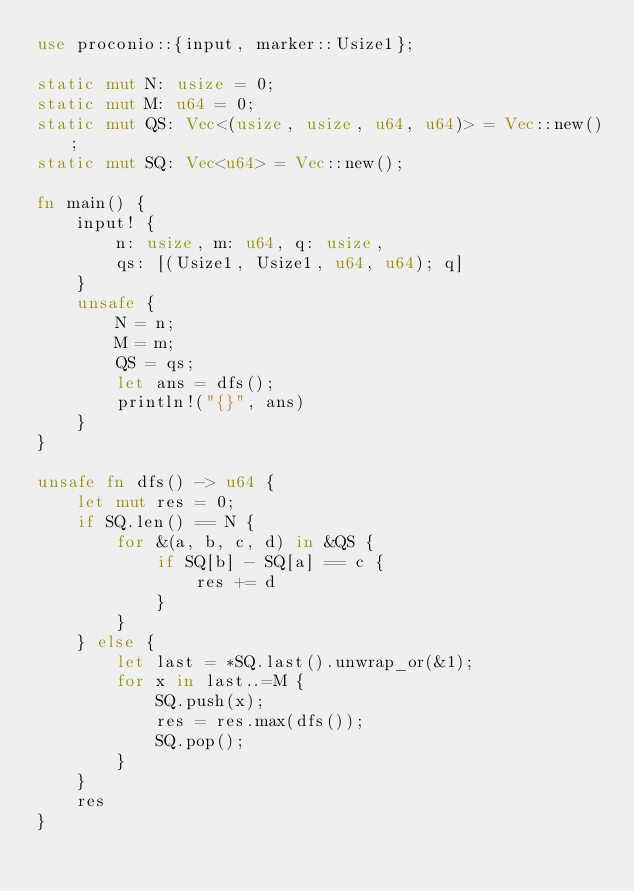<code> <loc_0><loc_0><loc_500><loc_500><_Rust_>use proconio::{input, marker::Usize1};

static mut N: usize = 0;
static mut M: u64 = 0;
static mut QS: Vec<(usize, usize, u64, u64)> = Vec::new();
static mut SQ: Vec<u64> = Vec::new();

fn main() {
    input! {
        n: usize, m: u64, q: usize,
        qs: [(Usize1, Usize1, u64, u64); q]
    }
    unsafe {
        N = n;
        M = m;
        QS = qs;
        let ans = dfs();
        println!("{}", ans)
    }
}

unsafe fn dfs() -> u64 {
    let mut res = 0;
    if SQ.len() == N {
        for &(a, b, c, d) in &QS {
            if SQ[b] - SQ[a] == c {
                res += d
            }
        }
    } else {
        let last = *SQ.last().unwrap_or(&1);
        for x in last..=M {
            SQ.push(x);
            res = res.max(dfs());
            SQ.pop();
        }
    }
    res
}
</code> 